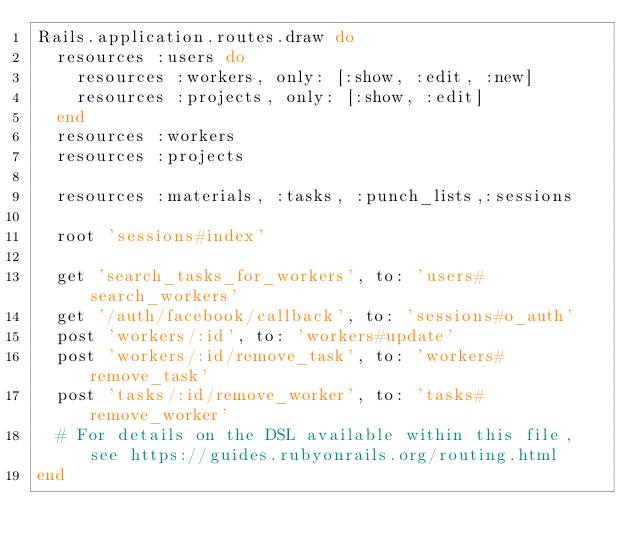Convert code to text. <code><loc_0><loc_0><loc_500><loc_500><_Ruby_>Rails.application.routes.draw do
  resources :users do
    resources :workers, only: [:show, :edit, :new]
    resources :projects, only: [:show, :edit]
  end
  resources :workers
  resources :projects

  resources :materials, :tasks, :punch_lists,:sessions
  
  root 'sessions#index'

  get 'search_tasks_for_workers', to: 'users#search_workers'
  get '/auth/facebook/callback', to: 'sessions#o_auth'
  post 'workers/:id', to: 'workers#update'
  post 'workers/:id/remove_task', to: 'workers#remove_task'
  post 'tasks/:id/remove_worker', to: 'tasks#remove_worker'
  # For details on the DSL available within this file, see https://guides.rubyonrails.org/routing.html
end
</code> 